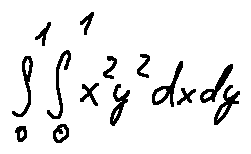<formula> <loc_0><loc_0><loc_500><loc_500>\int \lim i t s _ { 0 } ^ { 1 } \int \lim i t s _ { 0 } ^ { 1 } x ^ { 2 } y ^ { 2 } d x d y</formula> 